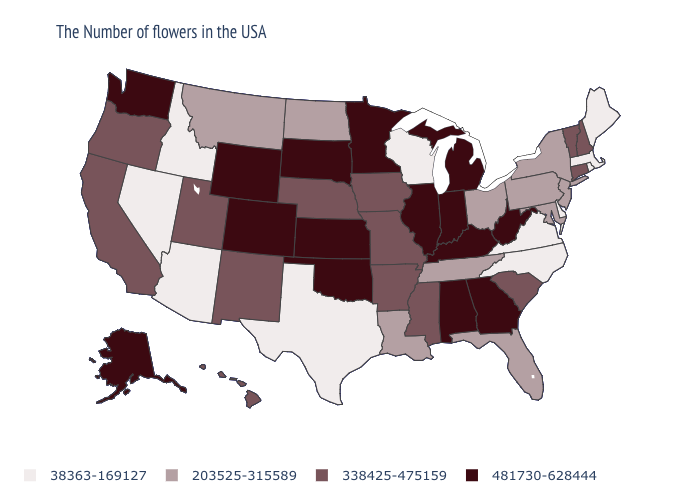Name the states that have a value in the range 481730-628444?
Give a very brief answer. West Virginia, Georgia, Michigan, Kentucky, Indiana, Alabama, Illinois, Minnesota, Kansas, Oklahoma, South Dakota, Wyoming, Colorado, Washington, Alaska. How many symbols are there in the legend?
Concise answer only. 4. How many symbols are there in the legend?
Be succinct. 4. Does the first symbol in the legend represent the smallest category?
Quick response, please. Yes. Does Colorado have the highest value in the West?
Answer briefly. Yes. Name the states that have a value in the range 481730-628444?
Give a very brief answer. West Virginia, Georgia, Michigan, Kentucky, Indiana, Alabama, Illinois, Minnesota, Kansas, Oklahoma, South Dakota, Wyoming, Colorado, Washington, Alaska. Name the states that have a value in the range 203525-315589?
Be succinct. New York, New Jersey, Maryland, Pennsylvania, Ohio, Florida, Tennessee, Louisiana, North Dakota, Montana. Name the states that have a value in the range 338425-475159?
Write a very short answer. New Hampshire, Vermont, Connecticut, South Carolina, Mississippi, Missouri, Arkansas, Iowa, Nebraska, New Mexico, Utah, California, Oregon, Hawaii. What is the value of New Hampshire?
Answer briefly. 338425-475159. Does the map have missing data?
Give a very brief answer. No. Does the first symbol in the legend represent the smallest category?
Short answer required. Yes. Is the legend a continuous bar?
Answer briefly. No. 